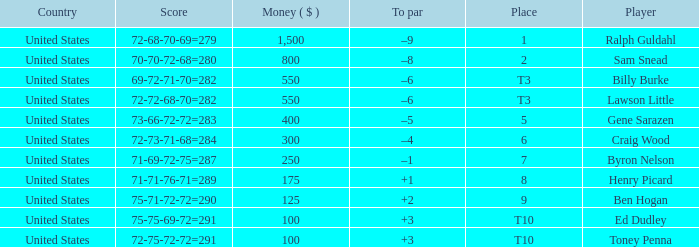Which country has a prize smaller than $250 and the player Henry Picard? United States. 